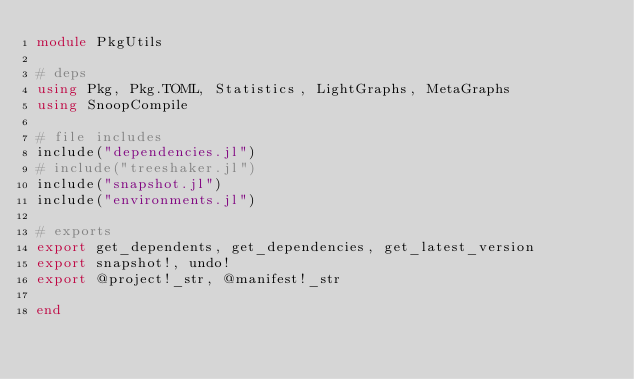Convert code to text. <code><loc_0><loc_0><loc_500><loc_500><_Julia_>module PkgUtils

# deps
using Pkg, Pkg.TOML, Statistics, LightGraphs, MetaGraphs
using SnoopCompile

# file includes
include("dependencies.jl")
# include("treeshaker.jl")
include("snapshot.jl")
include("environments.jl")

# exports
export get_dependents, get_dependencies, get_latest_version
export snapshot!, undo!
export @project!_str, @manifest!_str

end
</code> 